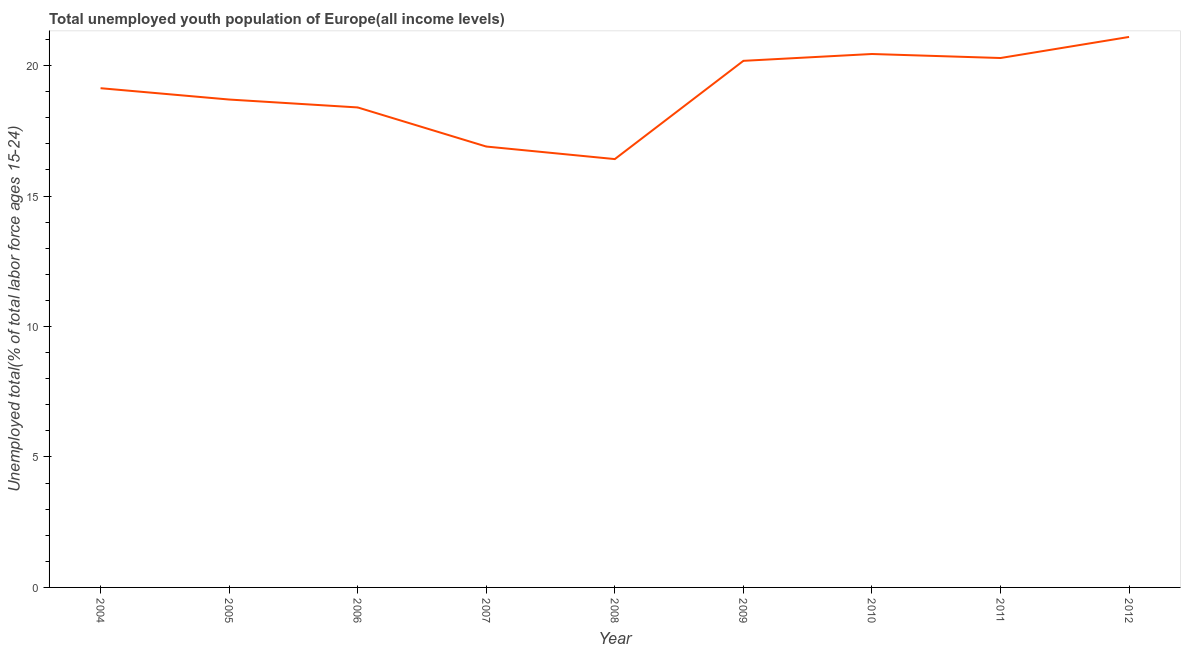What is the unemployed youth in 2006?
Offer a terse response. 18.4. Across all years, what is the maximum unemployed youth?
Your response must be concise. 21.1. Across all years, what is the minimum unemployed youth?
Provide a succinct answer. 16.42. What is the sum of the unemployed youth?
Offer a very short reply. 171.55. What is the difference between the unemployed youth in 2004 and 2006?
Give a very brief answer. 0.74. What is the average unemployed youth per year?
Provide a short and direct response. 19.06. What is the median unemployed youth?
Provide a succinct answer. 19.13. In how many years, is the unemployed youth greater than 13 %?
Offer a terse response. 9. Do a majority of the years between 2010 and 2006 (inclusive) have unemployed youth greater than 9 %?
Give a very brief answer. Yes. What is the ratio of the unemployed youth in 2004 to that in 2010?
Your answer should be very brief. 0.94. What is the difference between the highest and the second highest unemployed youth?
Offer a terse response. 0.65. What is the difference between the highest and the lowest unemployed youth?
Ensure brevity in your answer.  4.68. In how many years, is the unemployed youth greater than the average unemployed youth taken over all years?
Offer a very short reply. 5. How many years are there in the graph?
Your answer should be very brief. 9. Are the values on the major ticks of Y-axis written in scientific E-notation?
Provide a succinct answer. No. What is the title of the graph?
Offer a very short reply. Total unemployed youth population of Europe(all income levels). What is the label or title of the Y-axis?
Your answer should be very brief. Unemployed total(% of total labor force ages 15-24). What is the Unemployed total(% of total labor force ages 15-24) in 2004?
Your answer should be compact. 19.13. What is the Unemployed total(% of total labor force ages 15-24) of 2005?
Provide a short and direct response. 18.7. What is the Unemployed total(% of total labor force ages 15-24) of 2006?
Your response must be concise. 18.4. What is the Unemployed total(% of total labor force ages 15-24) of 2007?
Keep it short and to the point. 16.9. What is the Unemployed total(% of total labor force ages 15-24) in 2008?
Provide a succinct answer. 16.42. What is the Unemployed total(% of total labor force ages 15-24) in 2009?
Make the answer very short. 20.18. What is the Unemployed total(% of total labor force ages 15-24) of 2010?
Give a very brief answer. 20.44. What is the Unemployed total(% of total labor force ages 15-24) in 2011?
Ensure brevity in your answer.  20.29. What is the Unemployed total(% of total labor force ages 15-24) of 2012?
Your response must be concise. 21.1. What is the difference between the Unemployed total(% of total labor force ages 15-24) in 2004 and 2005?
Make the answer very short. 0.43. What is the difference between the Unemployed total(% of total labor force ages 15-24) in 2004 and 2006?
Make the answer very short. 0.74. What is the difference between the Unemployed total(% of total labor force ages 15-24) in 2004 and 2007?
Your answer should be compact. 2.24. What is the difference between the Unemployed total(% of total labor force ages 15-24) in 2004 and 2008?
Provide a succinct answer. 2.72. What is the difference between the Unemployed total(% of total labor force ages 15-24) in 2004 and 2009?
Give a very brief answer. -1.05. What is the difference between the Unemployed total(% of total labor force ages 15-24) in 2004 and 2010?
Provide a succinct answer. -1.31. What is the difference between the Unemployed total(% of total labor force ages 15-24) in 2004 and 2011?
Provide a succinct answer. -1.16. What is the difference between the Unemployed total(% of total labor force ages 15-24) in 2004 and 2012?
Your answer should be very brief. -1.96. What is the difference between the Unemployed total(% of total labor force ages 15-24) in 2005 and 2006?
Provide a succinct answer. 0.3. What is the difference between the Unemployed total(% of total labor force ages 15-24) in 2005 and 2007?
Ensure brevity in your answer.  1.8. What is the difference between the Unemployed total(% of total labor force ages 15-24) in 2005 and 2008?
Make the answer very short. 2.28. What is the difference between the Unemployed total(% of total labor force ages 15-24) in 2005 and 2009?
Provide a short and direct response. -1.48. What is the difference between the Unemployed total(% of total labor force ages 15-24) in 2005 and 2010?
Offer a very short reply. -1.75. What is the difference between the Unemployed total(% of total labor force ages 15-24) in 2005 and 2011?
Provide a succinct answer. -1.59. What is the difference between the Unemployed total(% of total labor force ages 15-24) in 2005 and 2012?
Ensure brevity in your answer.  -2.4. What is the difference between the Unemployed total(% of total labor force ages 15-24) in 2006 and 2007?
Ensure brevity in your answer.  1.5. What is the difference between the Unemployed total(% of total labor force ages 15-24) in 2006 and 2008?
Provide a short and direct response. 1.98. What is the difference between the Unemployed total(% of total labor force ages 15-24) in 2006 and 2009?
Offer a very short reply. -1.79. What is the difference between the Unemployed total(% of total labor force ages 15-24) in 2006 and 2010?
Keep it short and to the point. -2.05. What is the difference between the Unemployed total(% of total labor force ages 15-24) in 2006 and 2011?
Provide a short and direct response. -1.89. What is the difference between the Unemployed total(% of total labor force ages 15-24) in 2006 and 2012?
Your answer should be compact. -2.7. What is the difference between the Unemployed total(% of total labor force ages 15-24) in 2007 and 2008?
Your answer should be compact. 0.48. What is the difference between the Unemployed total(% of total labor force ages 15-24) in 2007 and 2009?
Provide a short and direct response. -3.28. What is the difference between the Unemployed total(% of total labor force ages 15-24) in 2007 and 2010?
Give a very brief answer. -3.55. What is the difference between the Unemployed total(% of total labor force ages 15-24) in 2007 and 2011?
Keep it short and to the point. -3.39. What is the difference between the Unemployed total(% of total labor force ages 15-24) in 2007 and 2012?
Offer a very short reply. -4.2. What is the difference between the Unemployed total(% of total labor force ages 15-24) in 2008 and 2009?
Your response must be concise. -3.77. What is the difference between the Unemployed total(% of total labor force ages 15-24) in 2008 and 2010?
Ensure brevity in your answer.  -4.03. What is the difference between the Unemployed total(% of total labor force ages 15-24) in 2008 and 2011?
Provide a succinct answer. -3.87. What is the difference between the Unemployed total(% of total labor force ages 15-24) in 2008 and 2012?
Provide a succinct answer. -4.68. What is the difference between the Unemployed total(% of total labor force ages 15-24) in 2009 and 2010?
Your answer should be very brief. -0.26. What is the difference between the Unemployed total(% of total labor force ages 15-24) in 2009 and 2011?
Make the answer very short. -0.11. What is the difference between the Unemployed total(% of total labor force ages 15-24) in 2009 and 2012?
Your response must be concise. -0.92. What is the difference between the Unemployed total(% of total labor force ages 15-24) in 2010 and 2011?
Your answer should be compact. 0.15. What is the difference between the Unemployed total(% of total labor force ages 15-24) in 2010 and 2012?
Keep it short and to the point. -0.65. What is the difference between the Unemployed total(% of total labor force ages 15-24) in 2011 and 2012?
Keep it short and to the point. -0.81. What is the ratio of the Unemployed total(% of total labor force ages 15-24) in 2004 to that in 2006?
Offer a very short reply. 1.04. What is the ratio of the Unemployed total(% of total labor force ages 15-24) in 2004 to that in 2007?
Your answer should be compact. 1.13. What is the ratio of the Unemployed total(% of total labor force ages 15-24) in 2004 to that in 2008?
Provide a succinct answer. 1.17. What is the ratio of the Unemployed total(% of total labor force ages 15-24) in 2004 to that in 2009?
Make the answer very short. 0.95. What is the ratio of the Unemployed total(% of total labor force ages 15-24) in 2004 to that in 2010?
Your answer should be very brief. 0.94. What is the ratio of the Unemployed total(% of total labor force ages 15-24) in 2004 to that in 2011?
Offer a terse response. 0.94. What is the ratio of the Unemployed total(% of total labor force ages 15-24) in 2004 to that in 2012?
Make the answer very short. 0.91. What is the ratio of the Unemployed total(% of total labor force ages 15-24) in 2005 to that in 2007?
Your answer should be very brief. 1.11. What is the ratio of the Unemployed total(% of total labor force ages 15-24) in 2005 to that in 2008?
Offer a very short reply. 1.14. What is the ratio of the Unemployed total(% of total labor force ages 15-24) in 2005 to that in 2009?
Keep it short and to the point. 0.93. What is the ratio of the Unemployed total(% of total labor force ages 15-24) in 2005 to that in 2010?
Offer a terse response. 0.92. What is the ratio of the Unemployed total(% of total labor force ages 15-24) in 2005 to that in 2011?
Your answer should be very brief. 0.92. What is the ratio of the Unemployed total(% of total labor force ages 15-24) in 2005 to that in 2012?
Make the answer very short. 0.89. What is the ratio of the Unemployed total(% of total labor force ages 15-24) in 2006 to that in 2007?
Provide a short and direct response. 1.09. What is the ratio of the Unemployed total(% of total labor force ages 15-24) in 2006 to that in 2008?
Provide a succinct answer. 1.12. What is the ratio of the Unemployed total(% of total labor force ages 15-24) in 2006 to that in 2009?
Your answer should be very brief. 0.91. What is the ratio of the Unemployed total(% of total labor force ages 15-24) in 2006 to that in 2011?
Offer a terse response. 0.91. What is the ratio of the Unemployed total(% of total labor force ages 15-24) in 2006 to that in 2012?
Provide a succinct answer. 0.87. What is the ratio of the Unemployed total(% of total labor force ages 15-24) in 2007 to that in 2008?
Provide a succinct answer. 1.03. What is the ratio of the Unemployed total(% of total labor force ages 15-24) in 2007 to that in 2009?
Make the answer very short. 0.84. What is the ratio of the Unemployed total(% of total labor force ages 15-24) in 2007 to that in 2010?
Keep it short and to the point. 0.83. What is the ratio of the Unemployed total(% of total labor force ages 15-24) in 2007 to that in 2011?
Give a very brief answer. 0.83. What is the ratio of the Unemployed total(% of total labor force ages 15-24) in 2007 to that in 2012?
Provide a short and direct response. 0.8. What is the ratio of the Unemployed total(% of total labor force ages 15-24) in 2008 to that in 2009?
Give a very brief answer. 0.81. What is the ratio of the Unemployed total(% of total labor force ages 15-24) in 2008 to that in 2010?
Your answer should be very brief. 0.8. What is the ratio of the Unemployed total(% of total labor force ages 15-24) in 2008 to that in 2011?
Provide a succinct answer. 0.81. What is the ratio of the Unemployed total(% of total labor force ages 15-24) in 2008 to that in 2012?
Your answer should be compact. 0.78. What is the ratio of the Unemployed total(% of total labor force ages 15-24) in 2009 to that in 2011?
Keep it short and to the point. 0.99. What is the ratio of the Unemployed total(% of total labor force ages 15-24) in 2009 to that in 2012?
Provide a short and direct response. 0.96. What is the ratio of the Unemployed total(% of total labor force ages 15-24) in 2010 to that in 2011?
Ensure brevity in your answer.  1.01. 